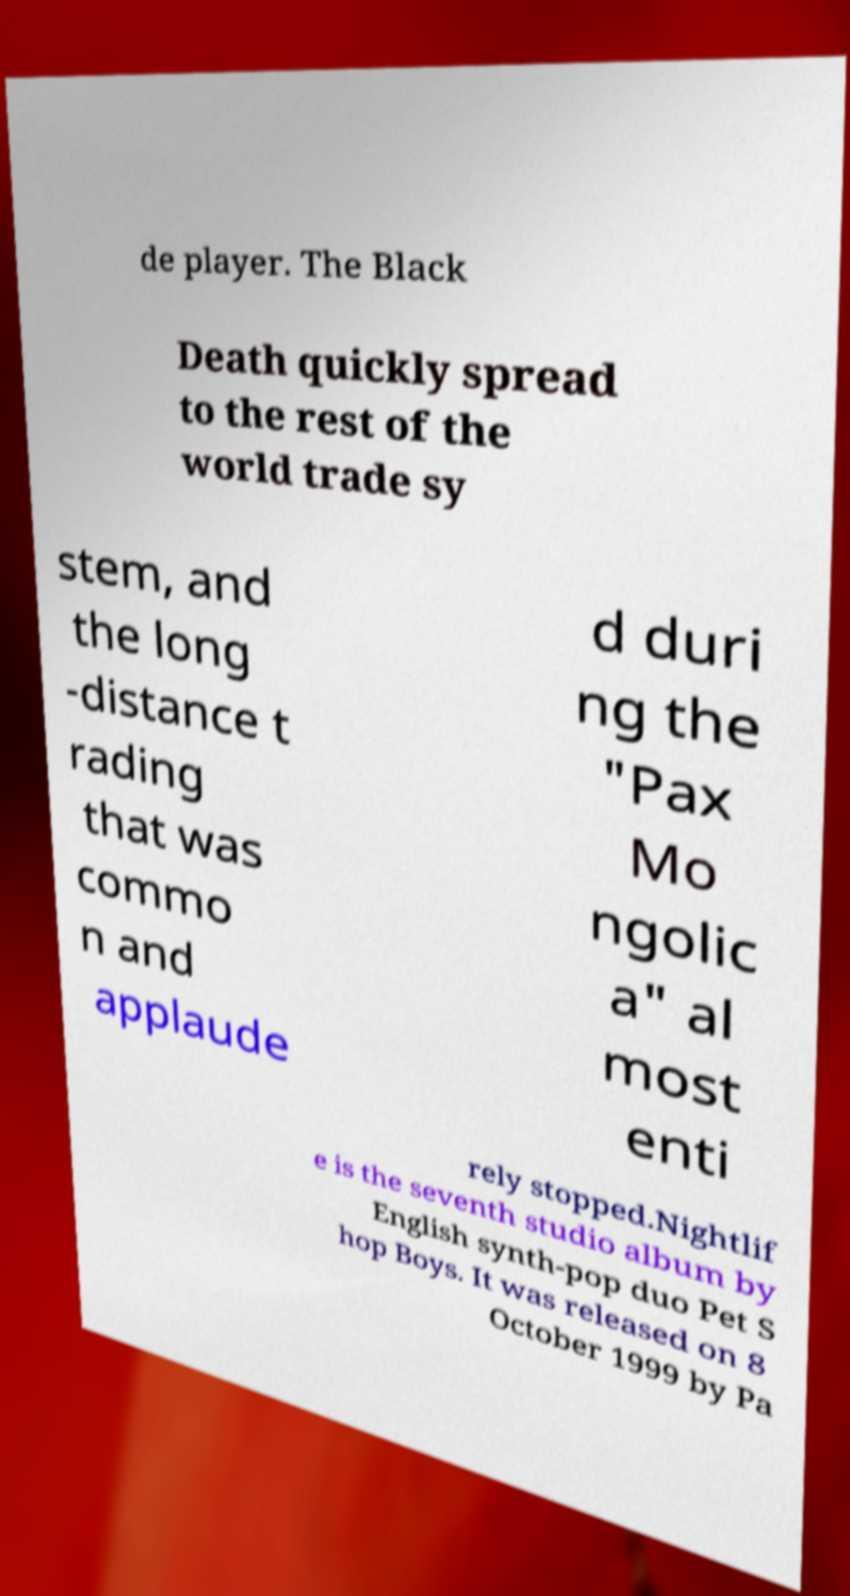Can you accurately transcribe the text from the provided image for me? de player. The Black Death quickly spread to the rest of the world trade sy stem, and the long -distance t rading that was commo n and applaude d duri ng the "Pax Mo ngolic a" al most enti rely stopped.Nightlif e is the seventh studio album by English synth-pop duo Pet S hop Boys. It was released on 8 October 1999 by Pa 